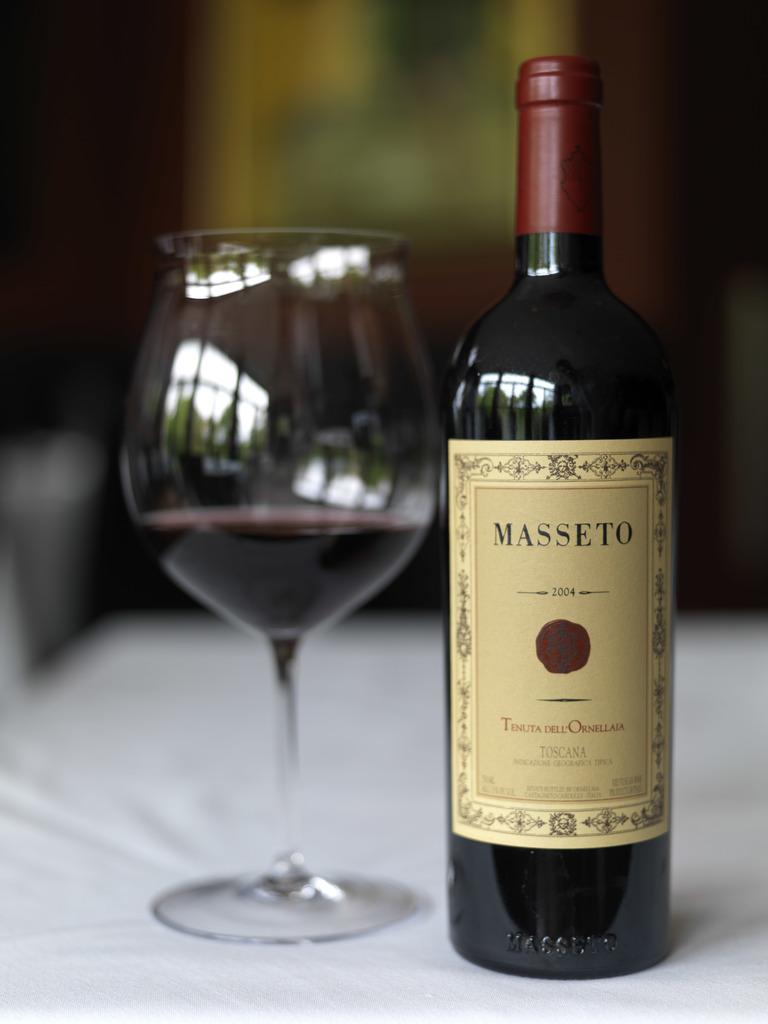What kind of wine is this?
Offer a terse response. Masseto. Is this wine?
Ensure brevity in your answer.  Yes. 